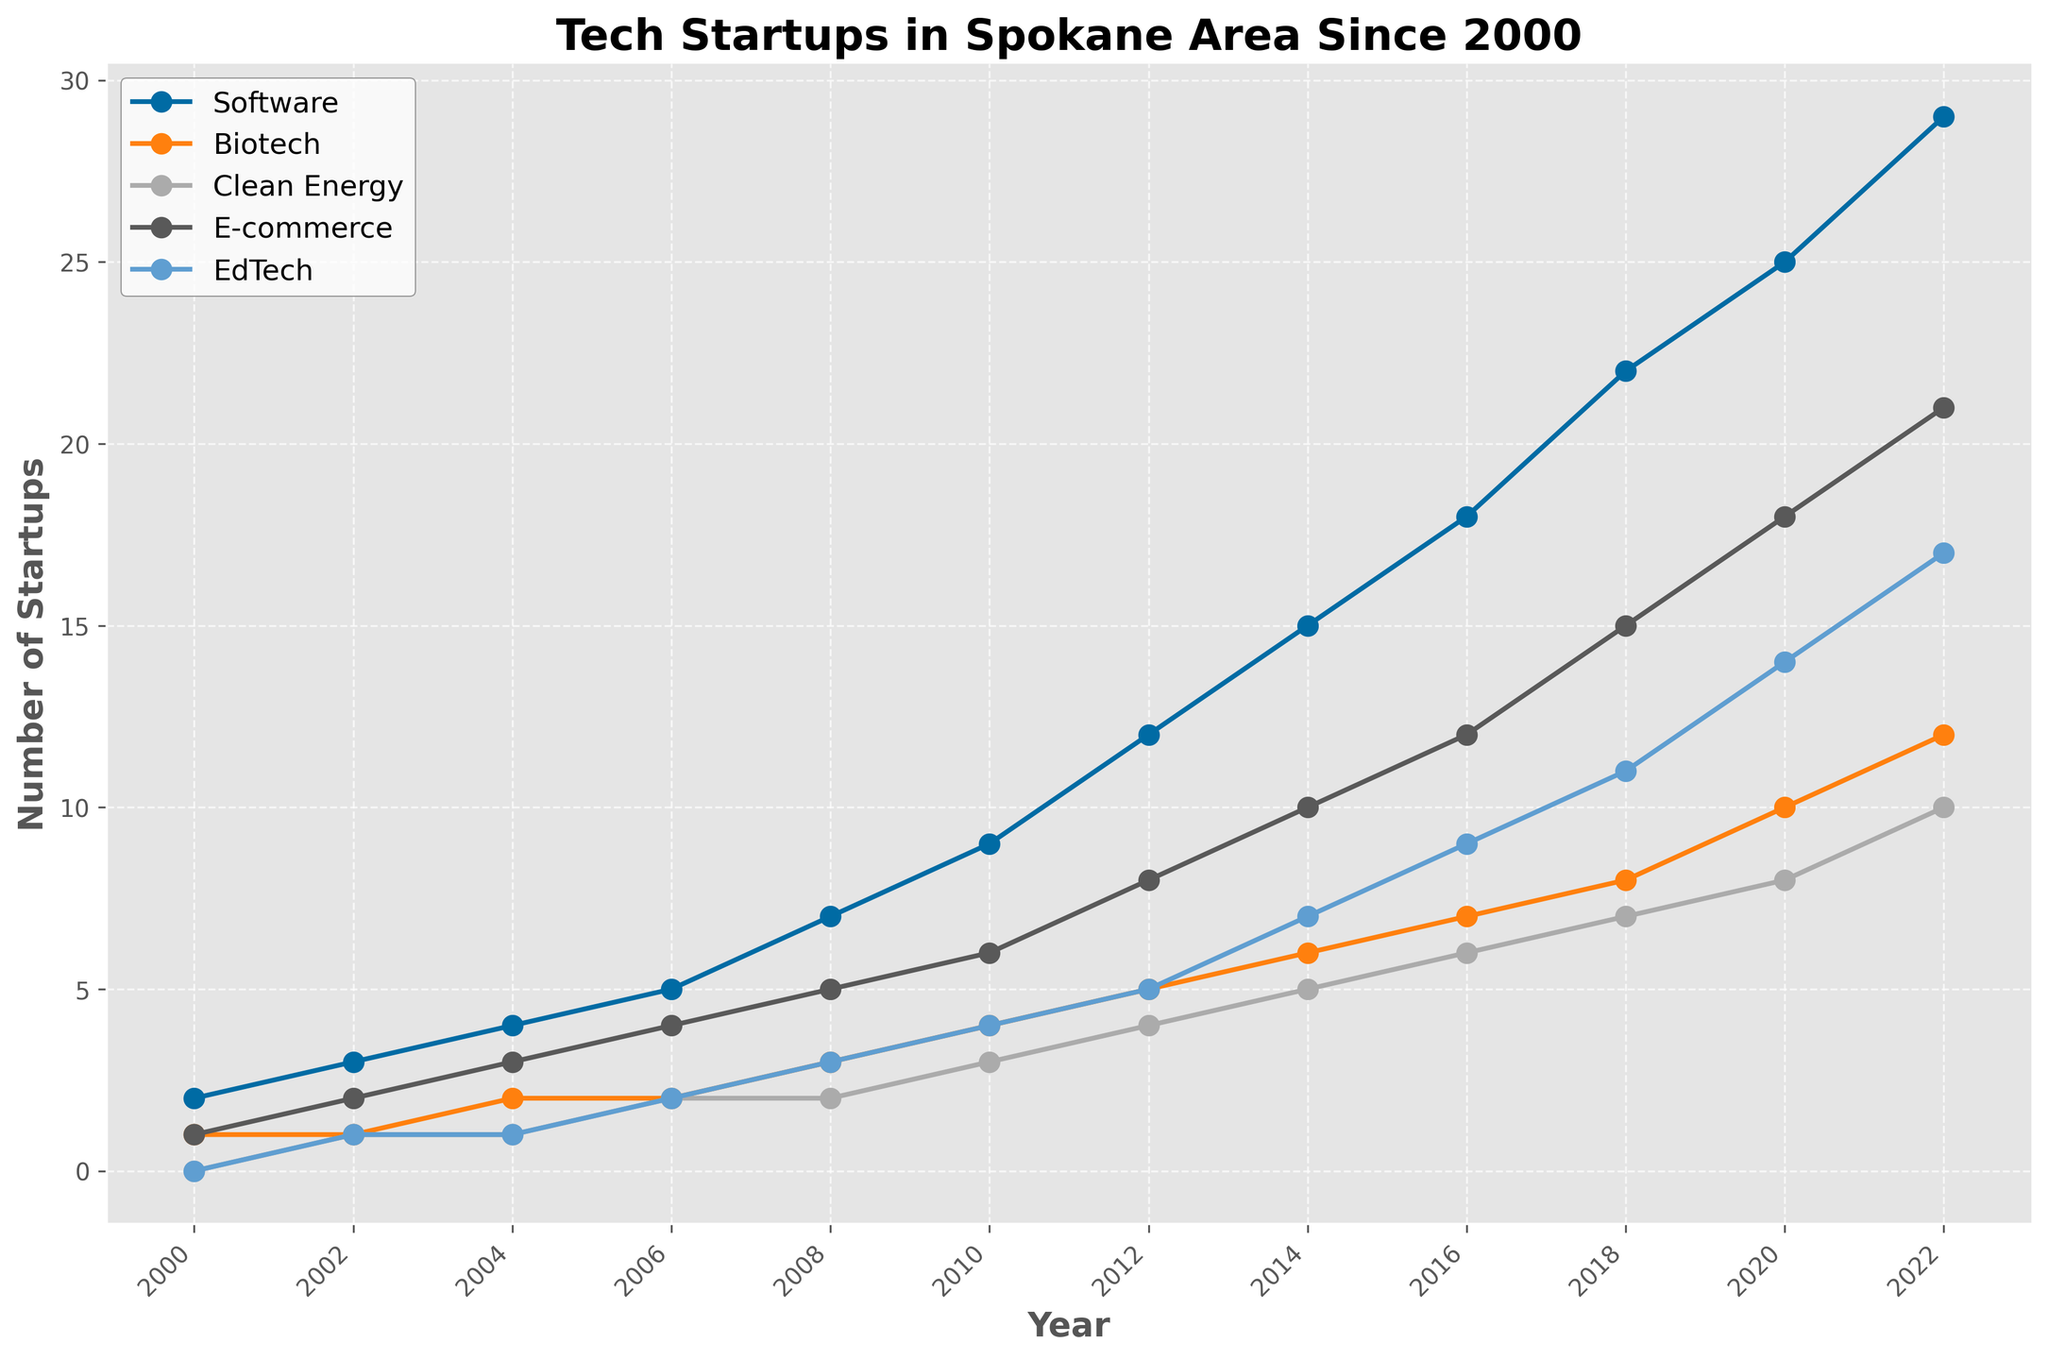Which industry showed the greatest increase in the number of startups from 2000 to 2022? To determine the industry with the greatest increase, calculate the difference in the number of startups between 2022 and 2000 for each industry, then compare these values. Software: 29-2 = 27; Biotech: 12-1 = 11; Clean Energy: 10-0 = 10; E-commerce: 21-1 = 20; EdTech: 17-0 = 17. The greatest increase is in Software with an increase of 27 startups.
Answer: Software Which two industries had the same number of startups founded in 2008? To find industries with the same number of startups in 2008, look at the values for that year. Software: 7, Biotech: 3, Clean Energy: 2, E-commerce: 5, EdTech: 3. Both Biotech and EdTech had 3 startups in 2008.
Answer: Biotech and EdTech What is the average number of E-commerce startups founded between 2004 and 2012? First, identify the number of E-commerce startups for each relevant year: 2004: 3, 2006: 4, 2008: 5, 2010: 6, 2012: 8. Then calculate the average: (3+4+5+6+8)/5 = 26/5 = 5.2.
Answer: 5.2 Which industry had the slowest growth rate in the number of startups from 2000 to 2022? Calculate the growth for each industry using the difference between 2022 and 2000: Software: 27; Biotech: 11; Clean Energy: 10; E-commerce: 20; EdTech: 17. The slowest growth rate is in Clean Energy with an increase of 10 startups.
Answer: Clean Energy How many more EdTech startups were founded in 2020 compared to 2014? Compare the number of EdTech startups in 2020 and 2014: In 2020: 14, in 2014: 7. The difference is 14-7 = 7.
Answer: 7 How many total tech startups were founded in 2016 across all industries? Sum the number of startups for all industries in 2016: Software: 18, Biotech: 7, Clean Energy: 6, E-commerce: 12, EdTech: 9. The total is 18+7+6+12+9 = 52.
Answer: 52 Which industry had consistent growth without any decrease in the number of startups from 2002 to 2022? Check the values of each industry year over year from 2002 to 2022 to identify any consistent increase without a decrease: Software, Biotech, and E-commerce all show continuous growth.
Answer: Software, Biotech, E-commerce In which year did the Clean Energy startups first exceed 5? Look for the first year where the Clean Energy startups count surpasses 5. This happened in 2022 with 10 startups.
Answer: 2022 By how many startups did Software surpass Biotech in 2018? Compare the number of startups for Software and Biotech in 2018: Software: 22, Biotech: 8. The difference is 22-8 = 14.
Answer: 14 What is the total number of Clean Energy startups founded from 2000 to 2008? Sum the number of Clean Energy startups for each year from 2000 to 2008: 2000: 0, 2002: 1, 2004: 1, 2006: 2, 2008: 2. The total is 0+1+1+2+2 = 6.
Answer: 6 